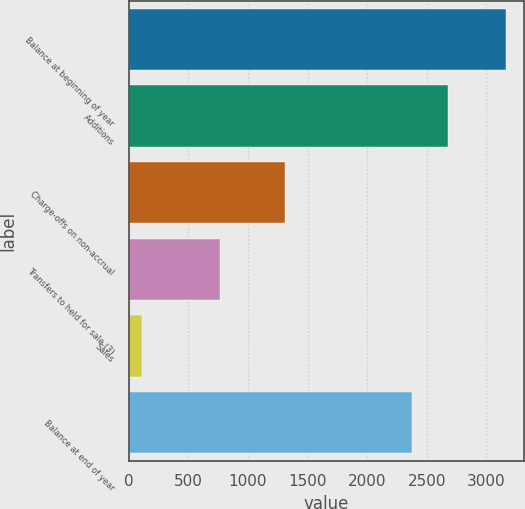<chart> <loc_0><loc_0><loc_500><loc_500><bar_chart><fcel>Balance at beginning of year<fcel>Additions<fcel>Charge-offs on non-accrual<fcel>Transfers to held for sale (3)<fcel>Sales<fcel>Balance at end of year<nl><fcel>3160<fcel>2676.6<fcel>1311<fcel>767<fcel>114<fcel>2372<nl></chart> 